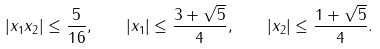<formula> <loc_0><loc_0><loc_500><loc_500>| x _ { 1 } x _ { 2 } | \leq \frac { 5 } { 1 6 } , \quad | x _ { 1 } | \leq \frac { 3 + \sqrt { 5 } } { 4 } , \quad | x _ { 2 } | \leq \frac { 1 + \sqrt { 5 } } { 4 } .</formula> 